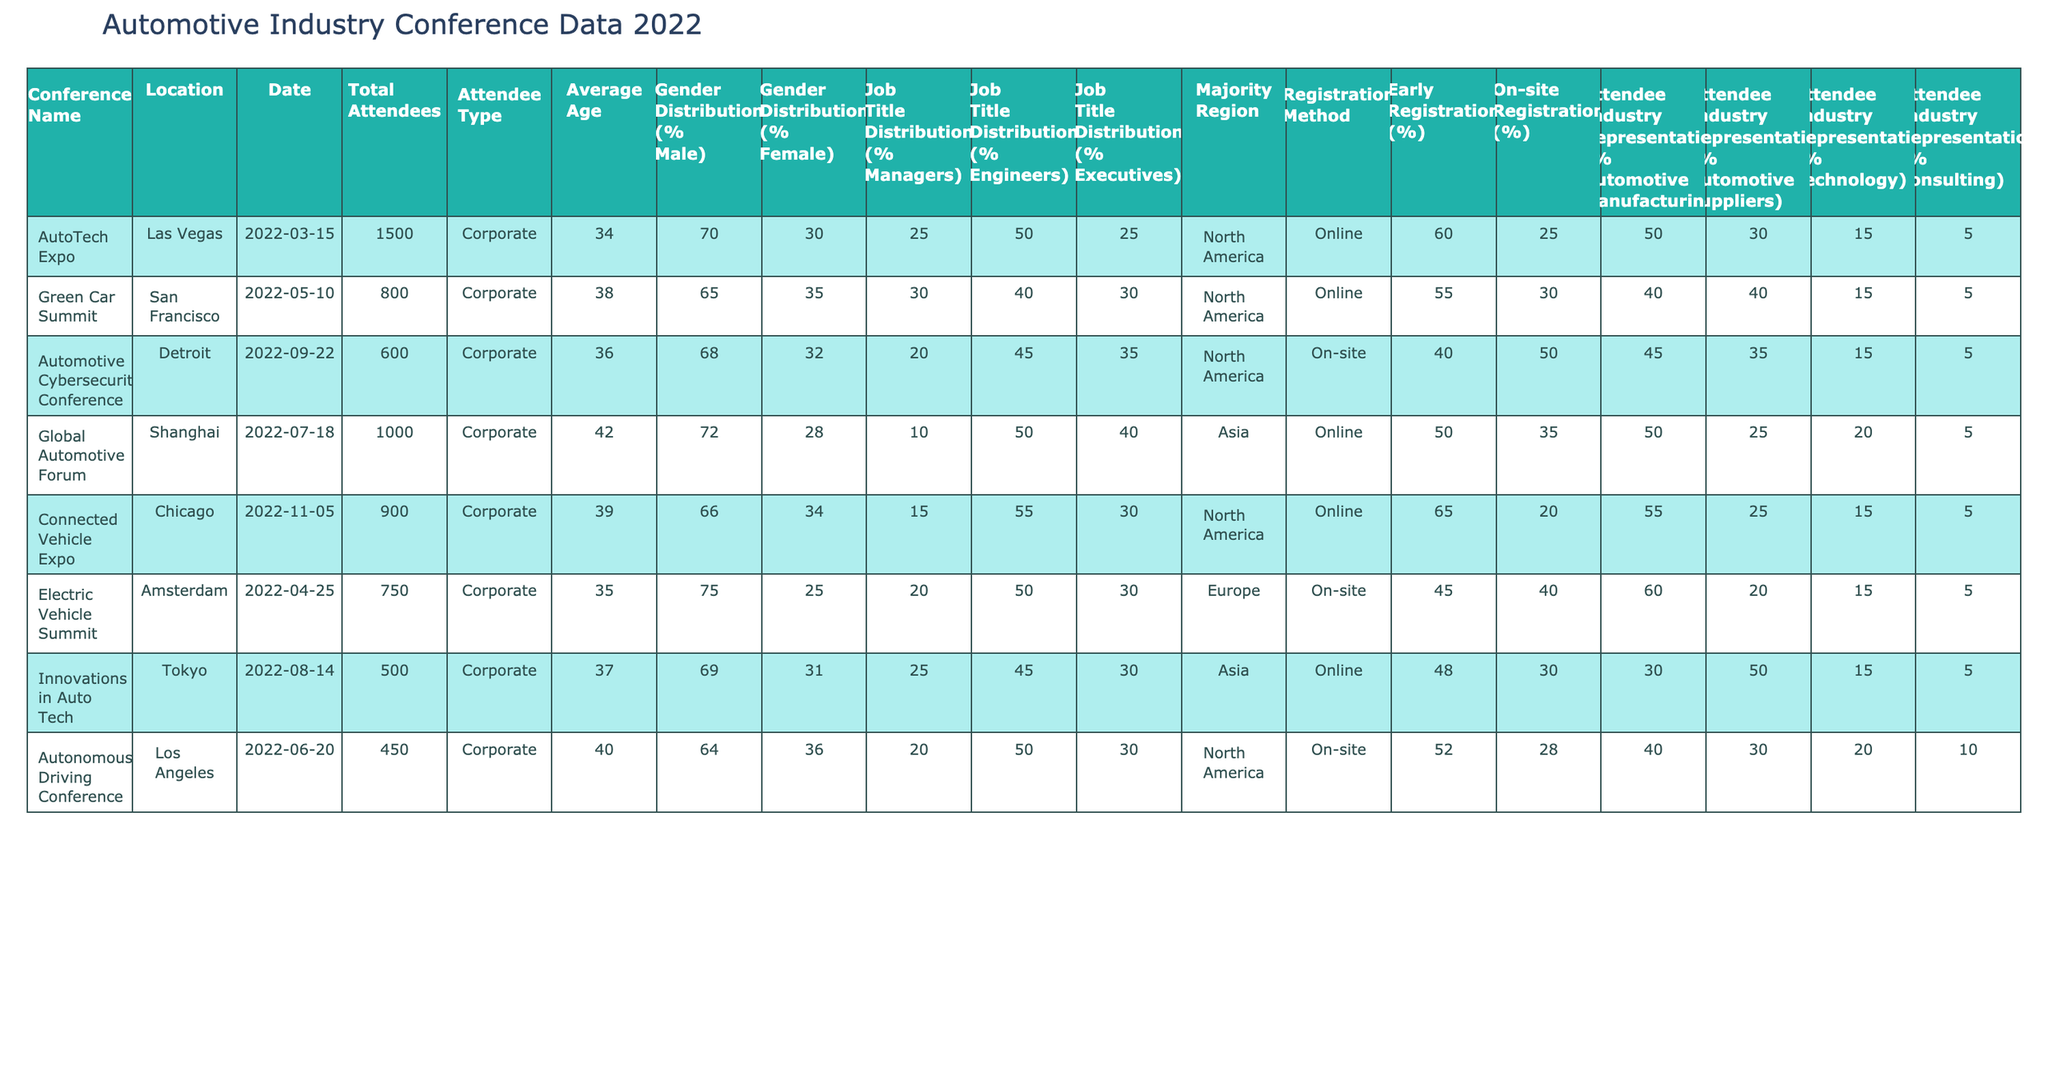What was the total number of attendees at the Green Car Summit? The table indicates the total number of attendees for each conference. For the Green Car Summit, the value in the "Total Attendees" column is 800.
Answer: 800 Which conference had the highest percentage of early registrations? To find this, we look at the "Early Registration (%)" column. The AutoTech Expo has the highest percentage at 60%.
Answer: 60% What is the average age of attendees at the Electric Vehicle Summit? According to the table, the "Average Age" for the Electric Vehicle Summit is listed as 35.
Answer: 35 How many attendees at the Autonomous Driving Conference are from the Automotive Manufacturing industry? The table shows that the percentage of attendees from the Automotive Manufacturing industry is 40%, and the total attendees are 450. Thus, the number of attendees from that industry is calculated as 0.4 * 450 = 180.
Answer: 180 Is the majority of attendees at the Global Automotive Forum located in North America? In the table, the "Majority Region" for the Global Automotive Forum is listed as Asia, not North America. Thus, the statement is false.
Answer: No What is the overall percentage of female attendees across all conferences? The percentages for female attendees can be summed across each conference: (30+35+32+28+34+25+31+36)/8 = 30.875%. The overall percentage rounds to 31%.
Answer: 31% Which conference had the lowest average age of attendees? By checking the "Average Age" column, the conference with the lowest age is the Electric Vehicle Summit at 35 years.
Answer: 35 What percentage of attendees registered on-site for the Connected Vehicle Expo? The table indicates that the percentage of on-site registrations for the Connected Vehicle Expo is 20%.
Answer: 20% Among the conferences listed, which had the highest representation from the Automotive Suppliers? The table shows the "Attendee Industry Representation (% Automotive Suppliers)" value for each conference. The highest value is 40% for the Green Car Summit.
Answer: 40% Calculate the difference in total attendees between the AutoTech Expo and the Innovations in Auto Tech conference. The total attendees for AutoTech Expo is 1500, and for Innovations in Auto Tech, it is 500. Thus, the difference is 1500 - 500 = 1000.
Answer: 1000 What is the combined percentage of managers and executives in the attendee job titles for the Automotive Cybersecurity Conference? The percentages for managers (20%) and executives (35%) are summed, leading to a total of 20 + 35 = 55%.
Answer: 55% Which conference had the highest gender diversity based on the percentage of female attendees? The conference with the highest percentage of female attendees is the Electric Vehicle Summit, with 25% female representation.
Answer: 25% How would you summarize the registration types for most conferences? By reviewing the "Registration Method" column, it's noted that five out of eight conferences have online registrations while three are on-site registrations. Thus, online registration is more prevalent.
Answer: Online registrations are more prevalent 